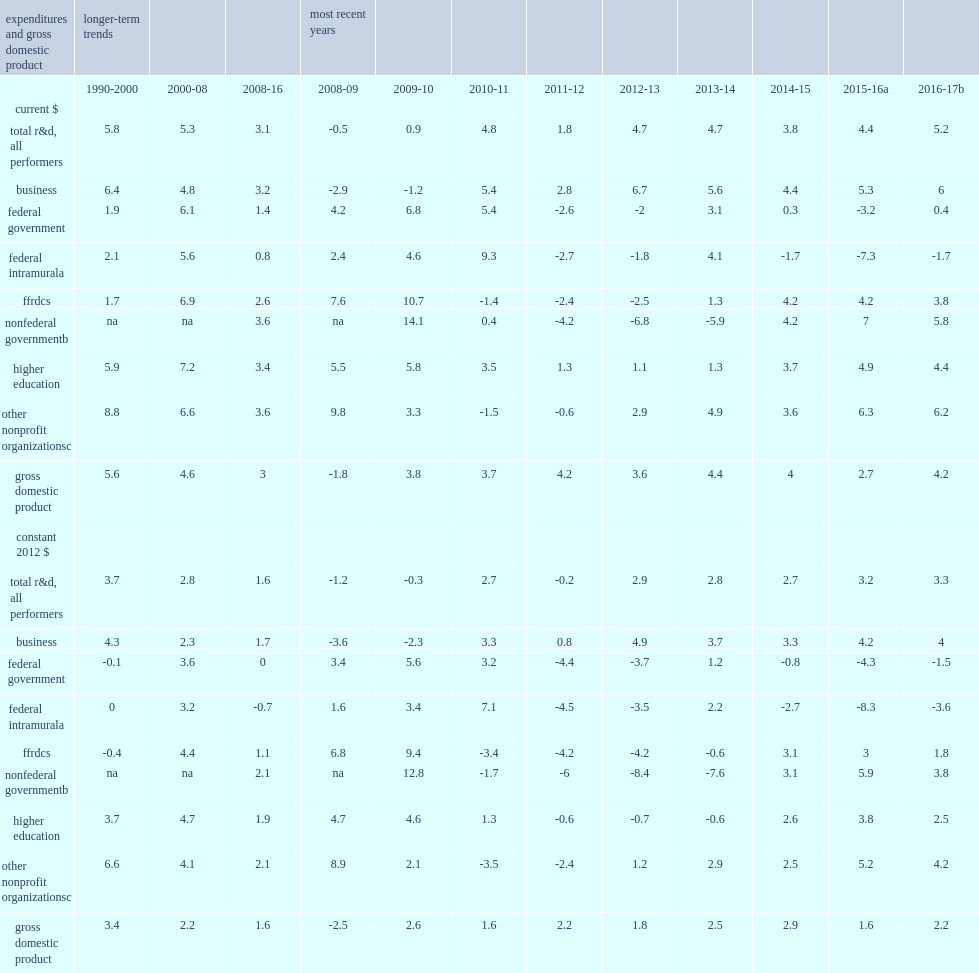Adjusted for inflation, what was the growth in u.s. total r&d averaged annually over the 8-year period 2008-16? 1.6. Adjusted for inflation, what was the average pace of u.s. gross domestic product (gdp) over the 8-year period 2008-16? 1.6. The average annual rate of r&d growth was notably higher in the prior 8-year period (2000-08), what was the percentage points for total r&d? 2.8. The average annual pace of gdp expansion was notably higher in the prior 8-year period (2000-08), what was the percentage points for gdp? 2.2. What is the average annual pace of growth for u.s. total r&d over 2010-16? 2.35. How many percentage points is the average annual rate of growth forgdp over 2010-16? 2.1. What is the estimate growth in u.s. total r&d in 2017? 3.3. What is the estimate growth for gdp in 2017? 2.2. 